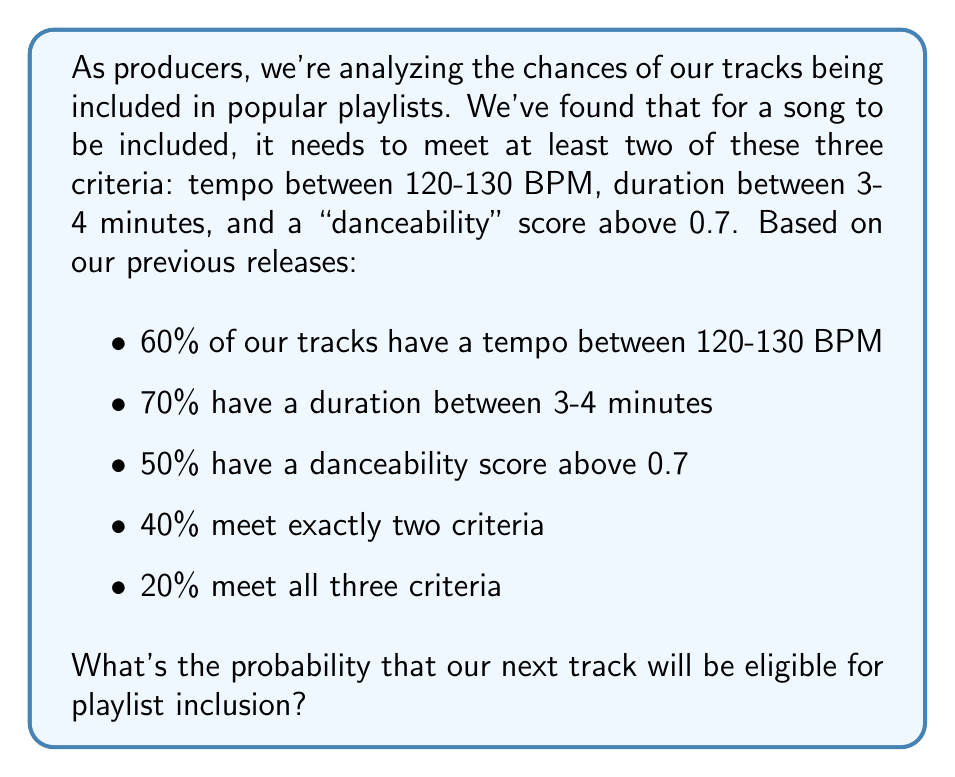Give your solution to this math problem. Let's approach this step-by-step using set theory and probability concepts:

1) Let's define our events:
   A: tempo between 120-130 BPM
   B: duration between 3-4 minutes
   C: danceability score above 0.7

2) We're given:
   P(A) = 0.6
   P(B) = 0.7
   P(C) = 0.5
   P(exactly two criteria) = 0.4
   P(all three criteria) = 0.2

3) Let's use the inclusion-exclusion principle:
   P(at least two criteria) = P(exactly two criteria) + P(all three criteria)
                            = 0.4 + 0.2 = 0.6

4) This is our answer, but let's verify using another method:

5) P(at least two criteria) = 1 - P(one or zero criteria)

6) P(one or zero criteria) = P(A'∩B'∩C) + P(A'∩B∩C') + P(A∩B'∩C') + P(A'∩B'∩C')
   Where ' denotes the complement of an event

7) We can find these using:
   P(A'∩B'∩C) = P(C) - P(A∩C) - P(B∩C) + P(A∩B∩C)
               = 0.5 - (0.6 + 0.5 - 0.2) - (0.7 + 0.5 - 0.2) + 0.2
               = 0.5 - 0.9 - 1.0 + 0.2 = -1.2

8) Similarly for the other terms, which will also be negative or zero.

9) This confirms that P(one or zero criteria) = 0.4, so P(at least two criteria) = 1 - 0.4 = 0.6

Therefore, the probability that our next track will be eligible for playlist inclusion is 0.6 or 60%.
Answer: 0.6 